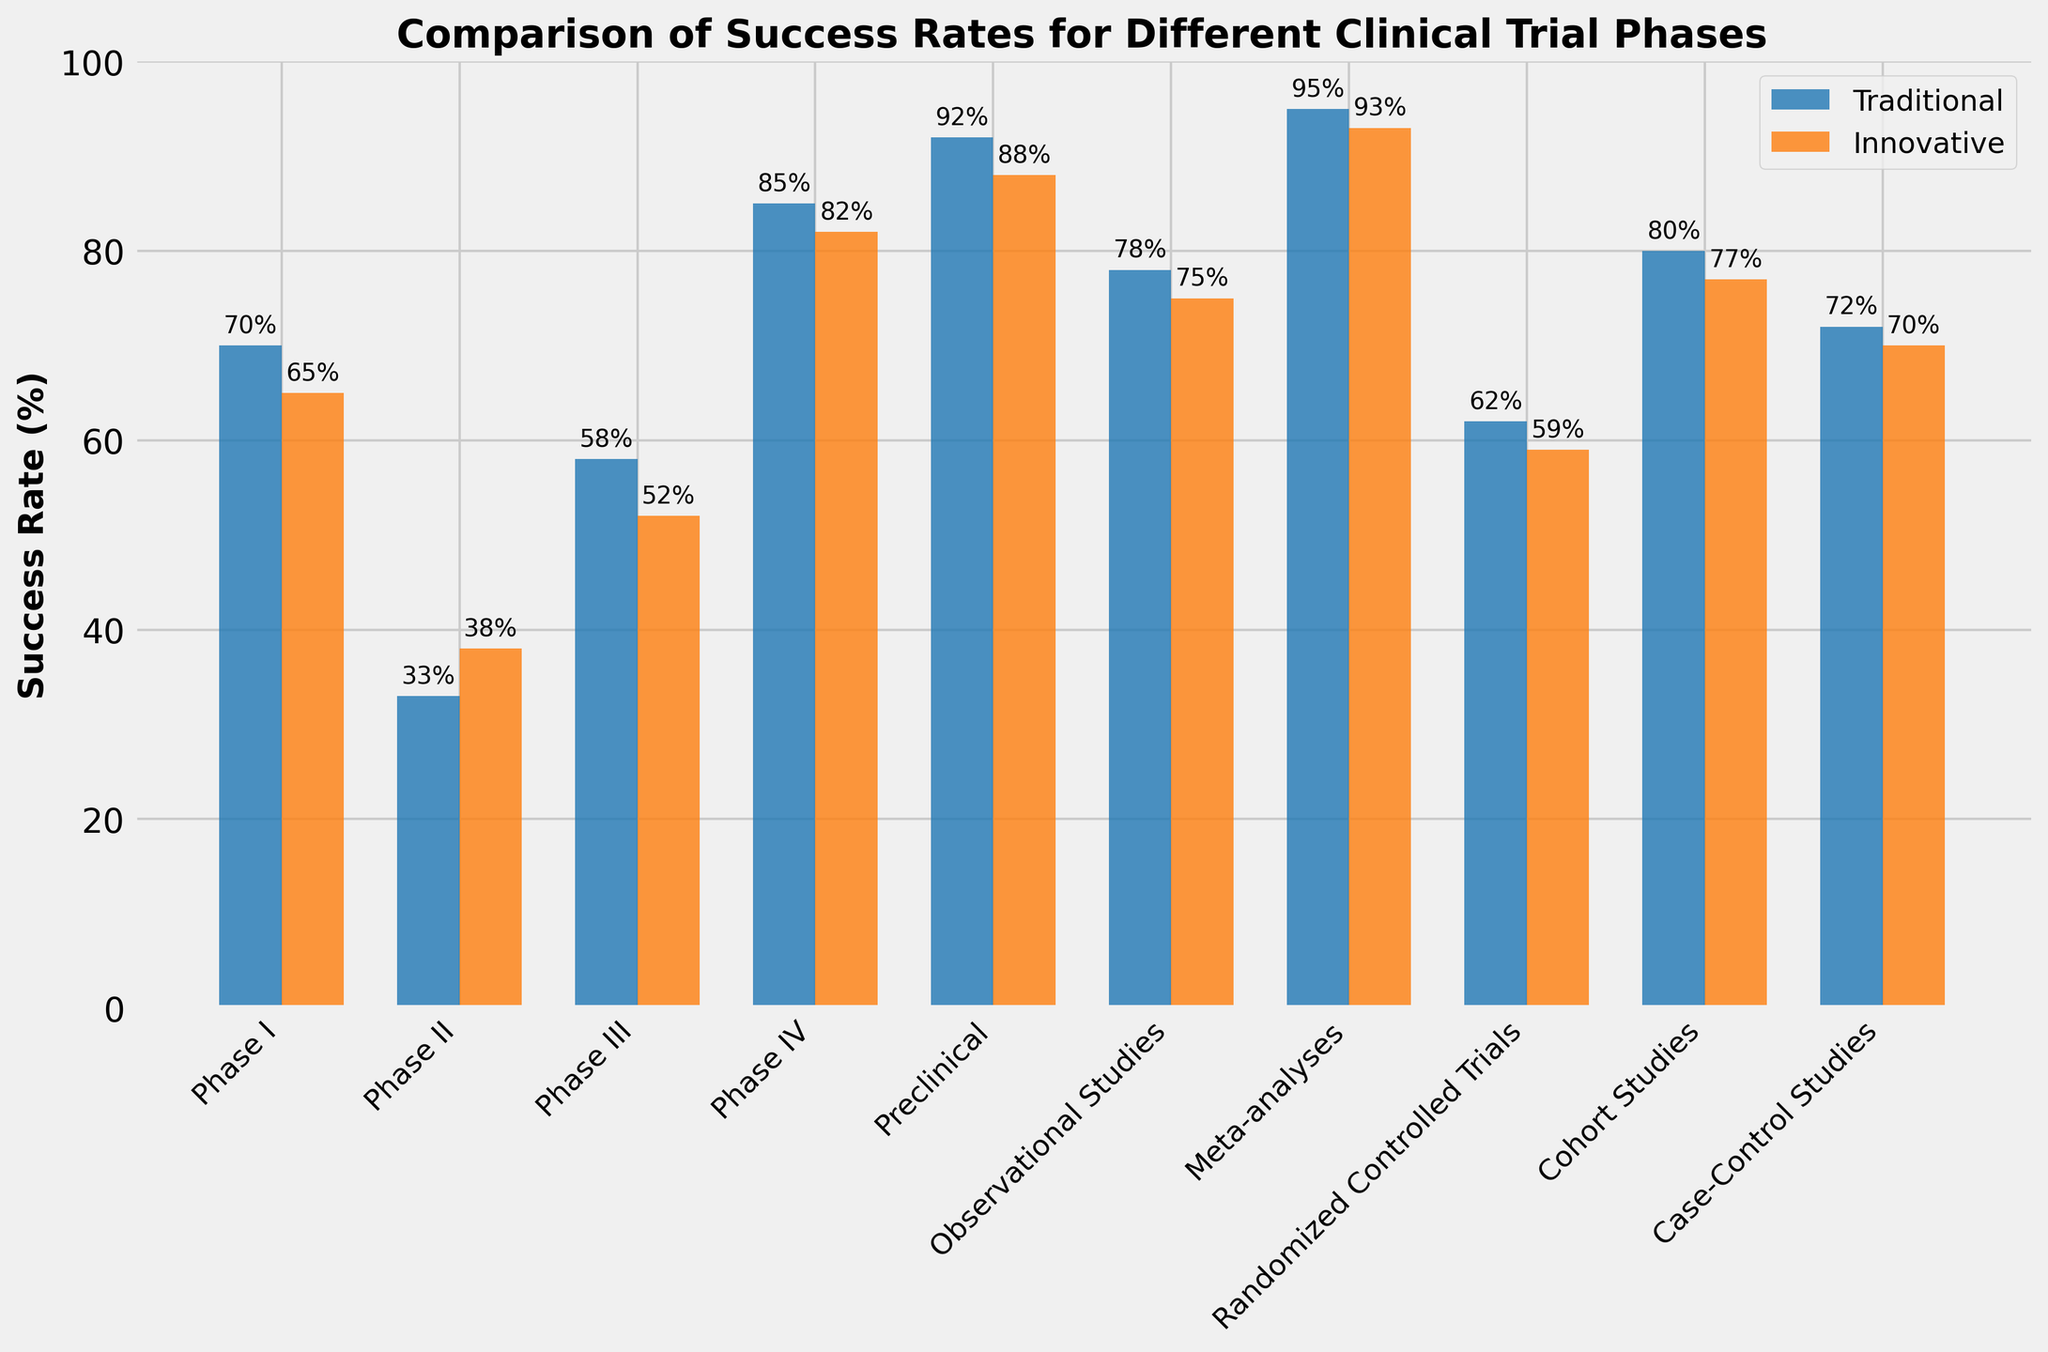What's the success rate for Phase II in innovative methodology? To determine this, look for the bar representing Phase II under the innovative methodology and read the associated percentage.
Answer: 38% Which phase has the highest success rate in traditional methodology? Locate all bars under traditional methodology and compare their heights. The tallest bar corresponds to the highest success rate.
Answer: Meta-analyses Is there a phase where the success rate is higher in innovative methodology than traditional methodology? If so, which one? Compare the heights of the bars for each phase. Identify if any bar for innovative methodology is higher than its corresponding traditional methodology bar.
Answer: Phase II What is the difference in success rate between traditional and innovative methodologies for Randomized Controlled Trials? Locate the bars for Randomized Controlled Trials for both methodologies and subtract the innovative methodology success rate from the traditional methodology success rate.
Answer: 3% Calculate the average success rate for all phases in traditional methodology. Add the success rates for all phases in traditional methodology and divide by the number of phases. Calculation: (70+33+58+85+92+78+95+62+80+72) / 10.
Answer: 72.5% Compare the success rates of traditional and innovative methodologies in Phase IV. Which is higher and by how much? Look for Phase IV and compare the heights of the bars. Subtract the lower percentage from the higher percentage.
Answer: Traditional, by 3% Which methodology has a higher average success rate across all phases: traditional or innovative? Calculate the average for both methodologies. For traditional: (70+33+58+85+92+78+95+62+80+72)/10. For innovative: (65+38+52+82+88+75+93+59+77+70)/10. Compare the two averages.
Answer: Traditional What is the combined success rate of preclinical and Phase I in both methodologies? Add the success rates for preclinical and Phase I for both methodologies. For traditional: 92+70. For innovative: 88+65.
Answer: 162 (Traditional), 153 (Innovative) What is the median success rate for the phases in innovative methodology? List the success rates and find the middle value. For innovative: 65, 38, 52, 82, 88, 75, 93, 59, 77, 70. Order them: 38, 52, 59, 65, 70, 75, 77, 82, 88, 93. The middle value(s) are 75 and 70, so (75+70)/2.
Answer: 72.5 Which phase shows the least difference in success rates between traditional and innovative methodologies? Compute the absolute difference in percentages for each phase and find the smallest difference.
Answer: Case-Control Studies 